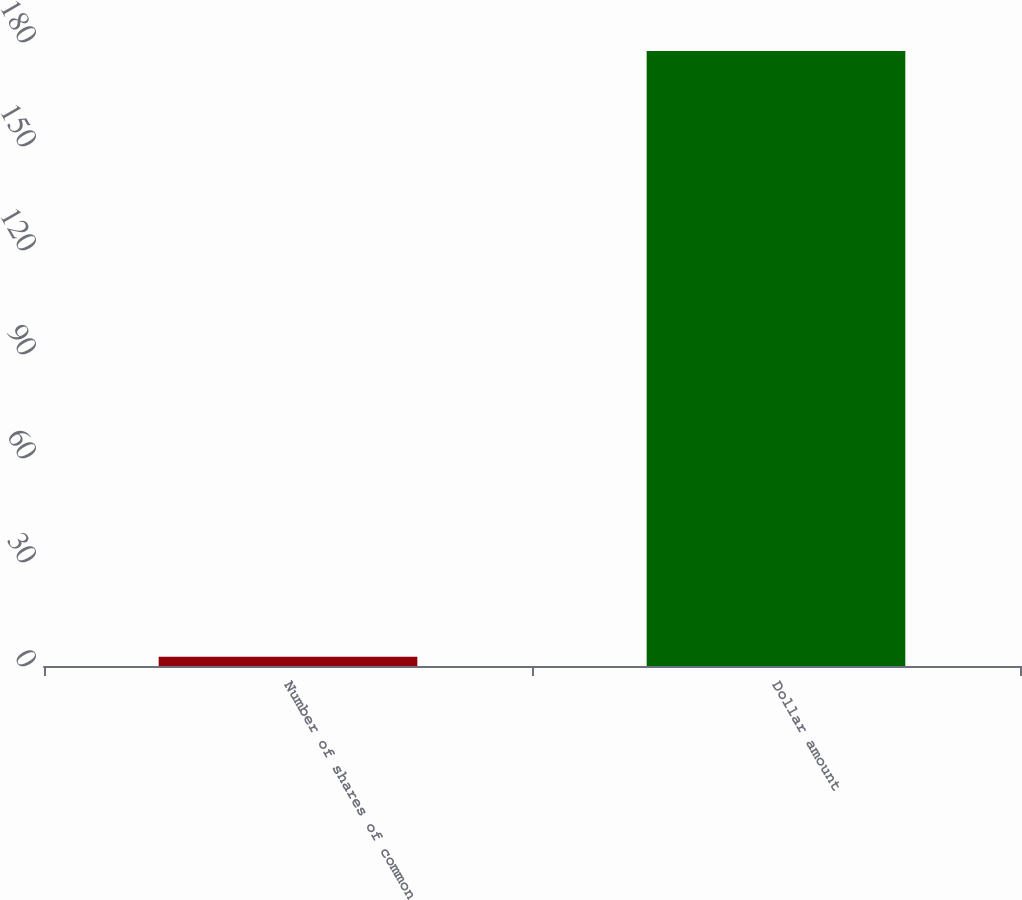<chart> <loc_0><loc_0><loc_500><loc_500><bar_chart><fcel>Number of shares of common<fcel>Dollar amount<nl><fcel>2.7<fcel>177.4<nl></chart> 